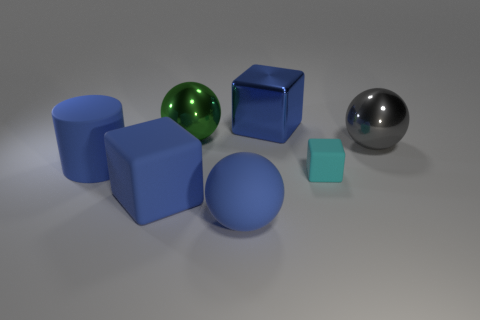Add 2 big gray objects. How many objects exist? 9 Subtract all cylinders. How many objects are left? 6 Subtract all large red matte blocks. Subtract all small matte objects. How many objects are left? 6 Add 3 blue metal blocks. How many blue metal blocks are left? 4 Add 4 shiny things. How many shiny things exist? 7 Subtract 0 purple blocks. How many objects are left? 7 